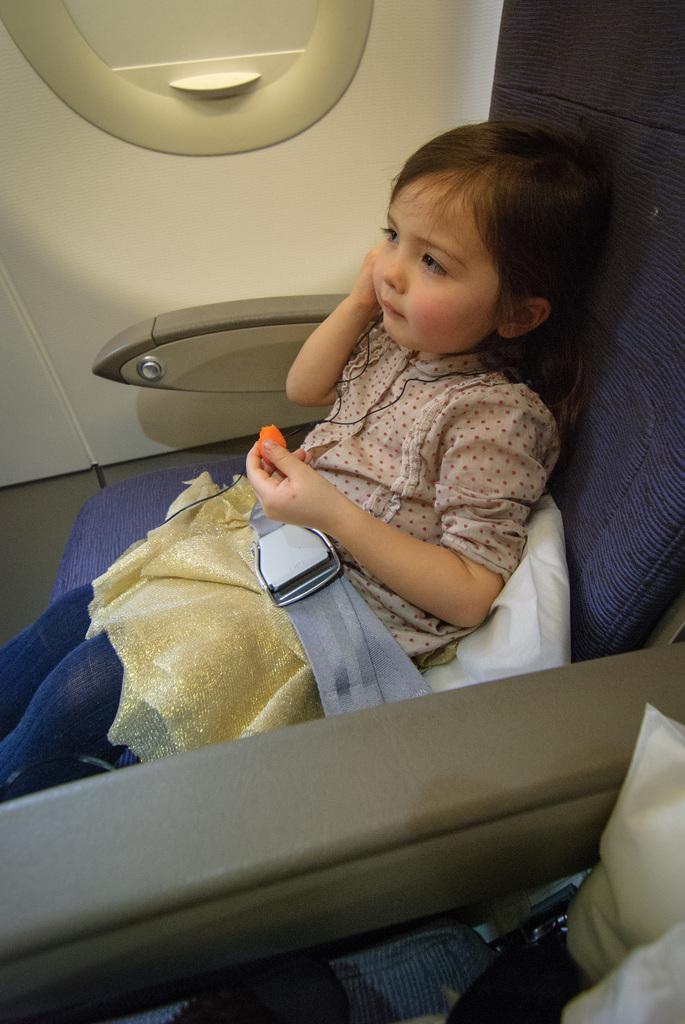Can you describe this image briefly? In this image a girl is sitting on a seat which is inside the vehicle. She is holding a object in her hand. Behind her there is a pillow. She is tied with a seat belt. Right bottom there are few packets. Left top there is a window to the wall. 